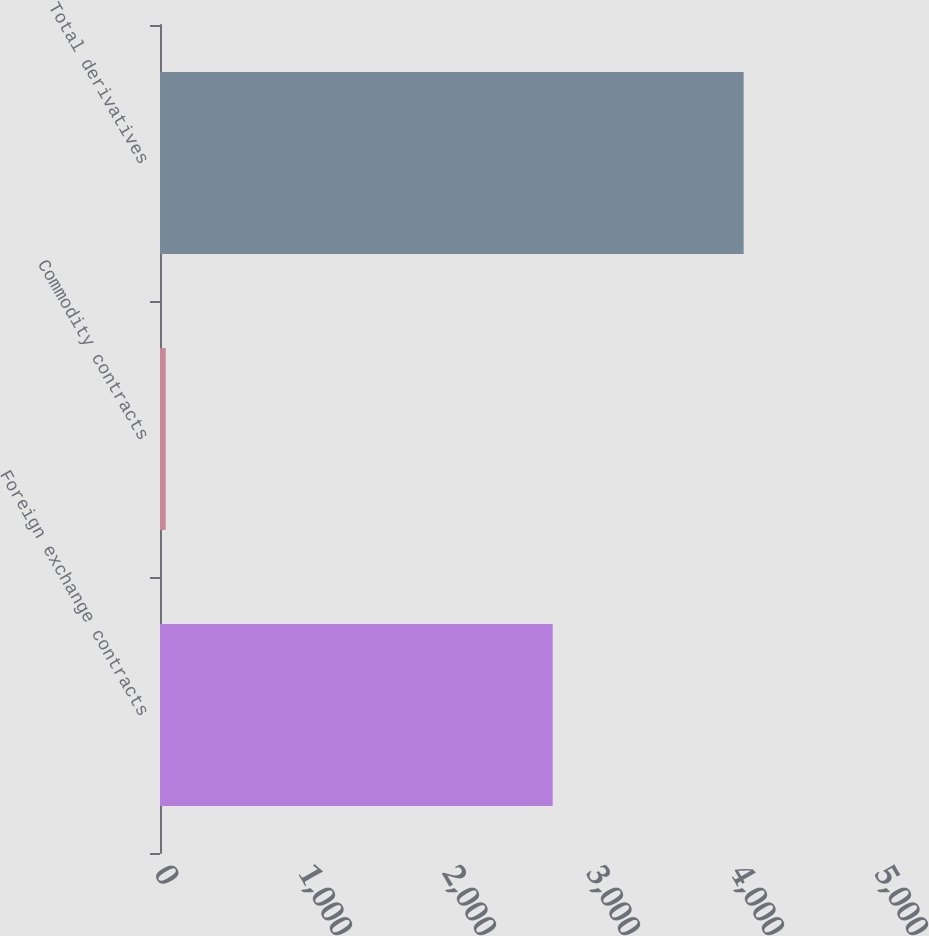Convert chart. <chart><loc_0><loc_0><loc_500><loc_500><bar_chart><fcel>Foreign exchange contracts<fcel>Commodity contracts<fcel>Total derivatives<nl><fcel>2727<fcel>40<fcel>4053<nl></chart> 